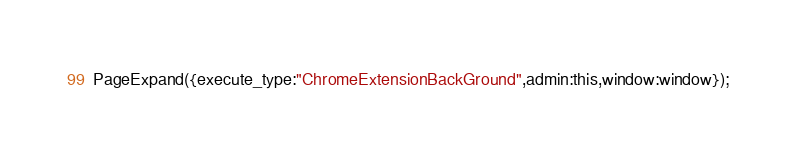<code> <loc_0><loc_0><loc_500><loc_500><_JavaScript_>PageExpand({execute_type:"ChromeExtensionBackGround",admin:this,window:window});</code> 